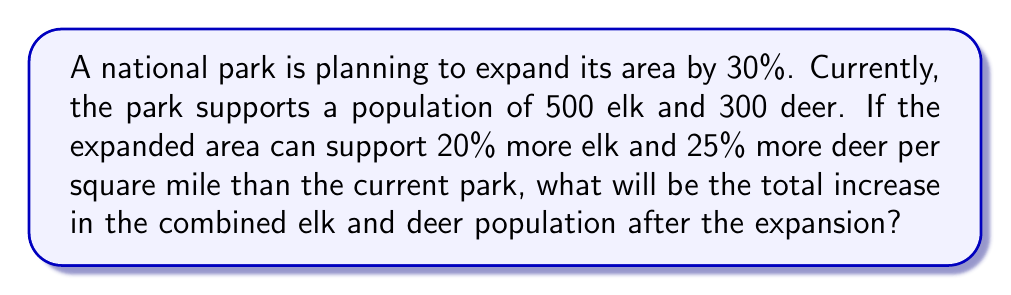Give your solution to this math problem. Let's approach this step-by-step:

1) First, let's calculate the new populations of elk and deer if the park size remained the same:

   Elk: $500 \times 1.20 = 600$
   Deer: $300 \times 1.25 = 375$

2) Now, we need to account for the 30% increase in park size:

   Elk: $600 \times 1.30 = 780$
   Deer: $375 \times 1.30 = 487.5$

3) Let's round down the deer population to 487 (we can't have half a deer).

4) Now, let's calculate the total increase:

   Elk increase: $780 - 500 = 280$
   Deer increase: $487 - 300 = 187$

5) Total increase:

   $280 + 187 = 467$

Therefore, the total increase in the combined elk and deer population after the expansion will be 467.
Answer: 467 